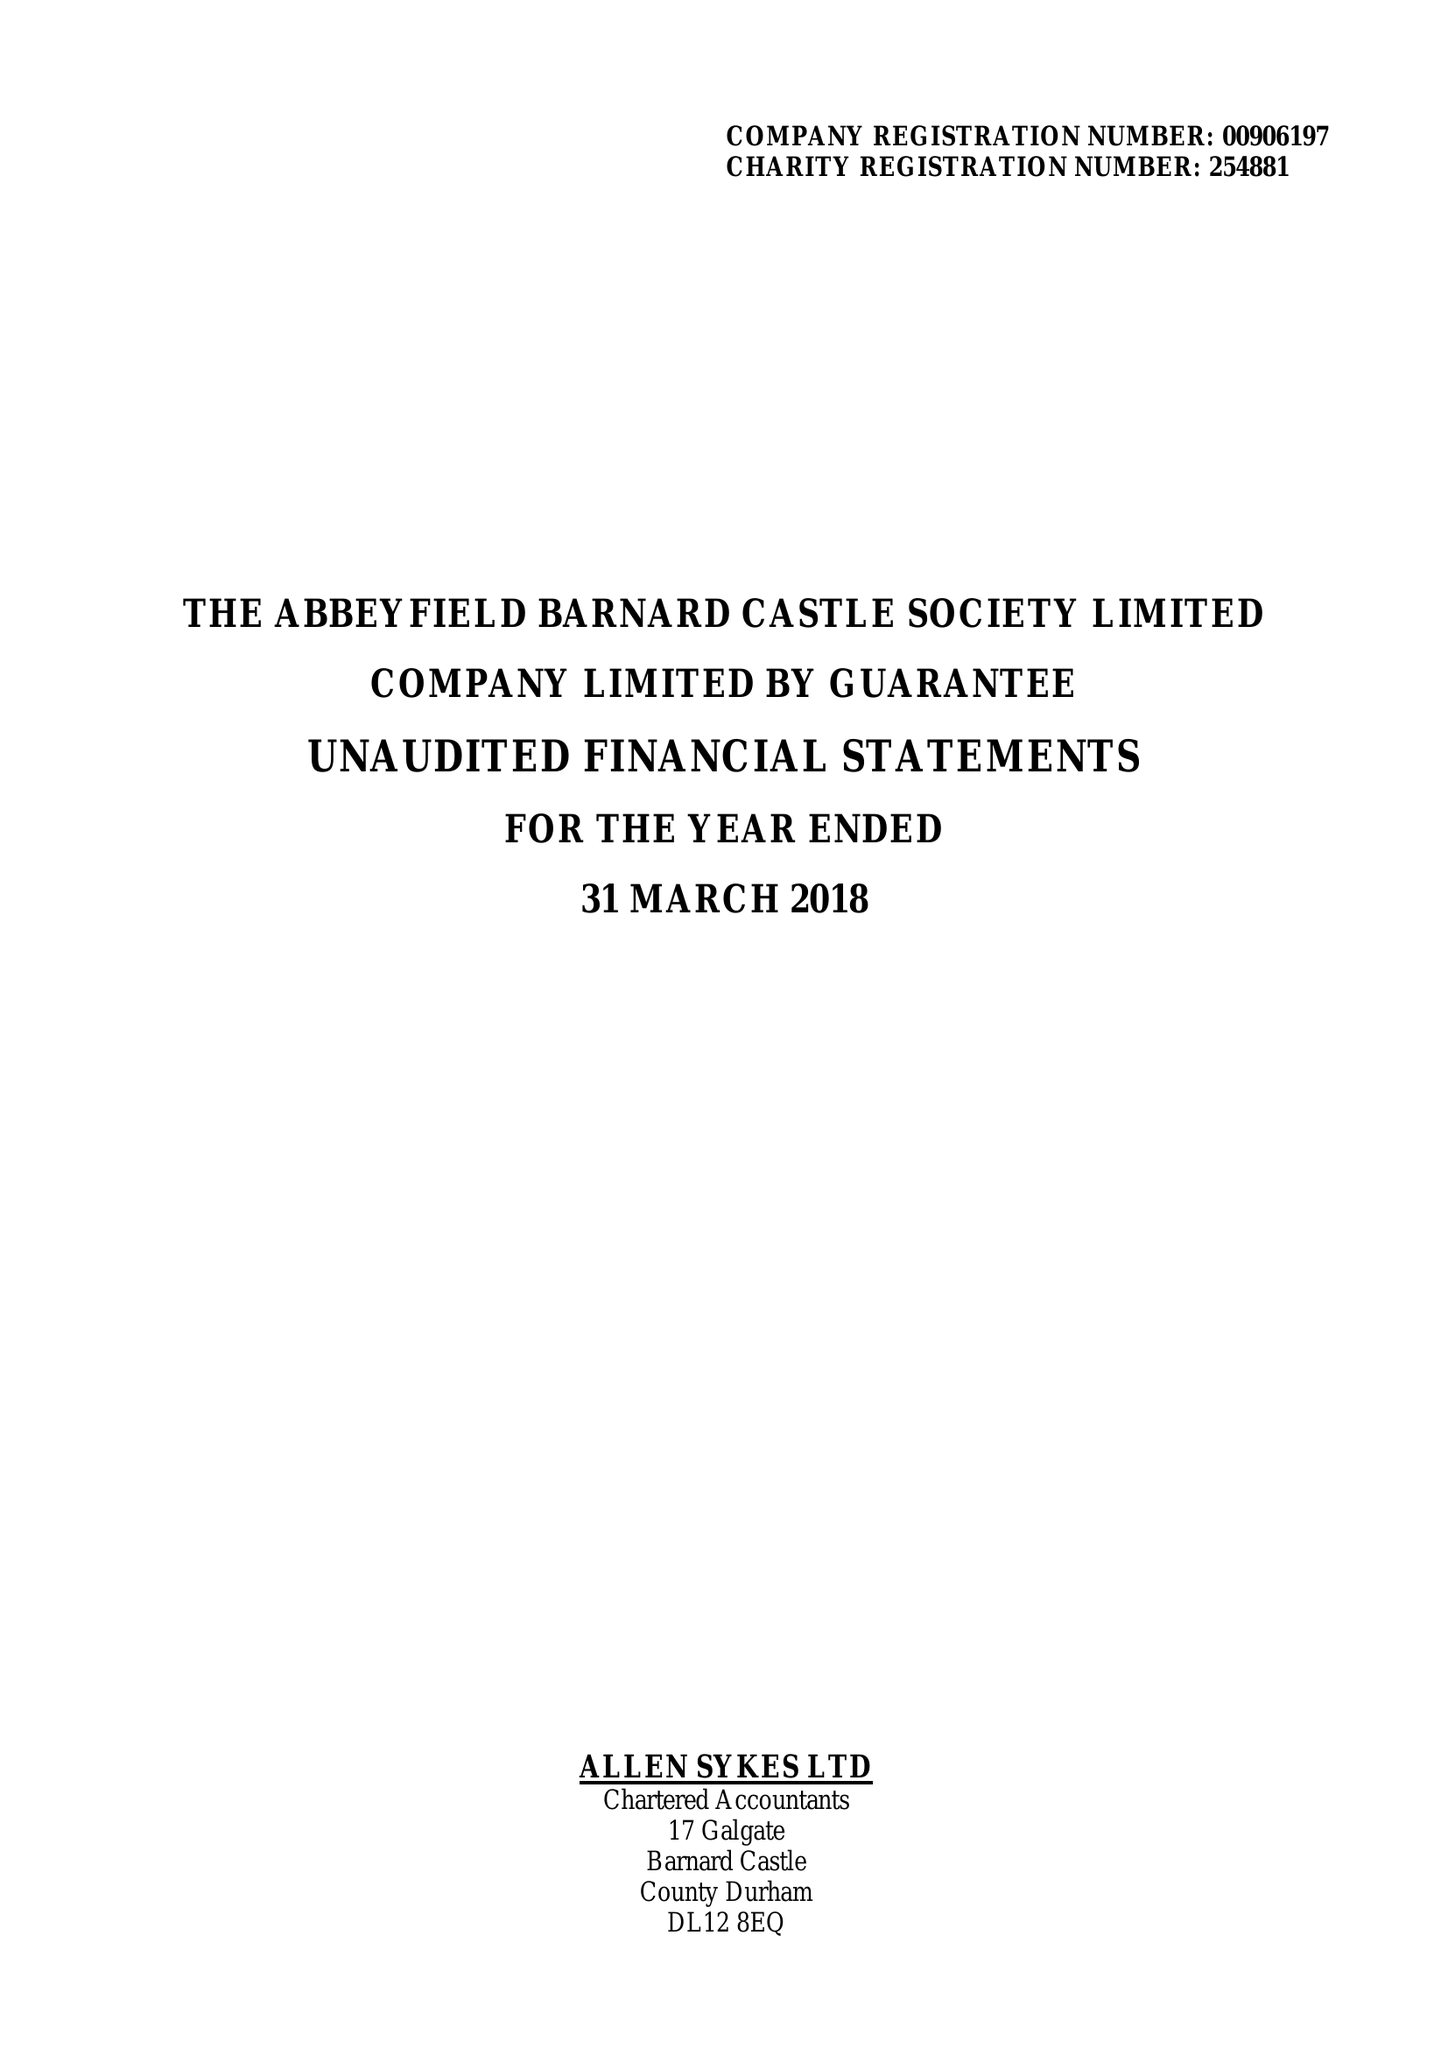What is the value for the charity_name?
Answer the question using a single word or phrase. The Abbeyfield Barnard Castle Society Ltd. 